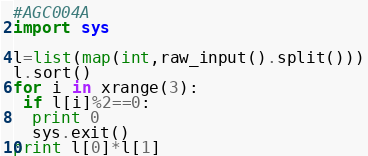<code> <loc_0><loc_0><loc_500><loc_500><_Python_>#AGC004A
import sys

l=list(map(int,raw_input().split()))
l.sort()
for i in xrange(3):
 if l[i]%2==0:
  print 0
  sys.exit()
print l[0]*l[1]
</code> 